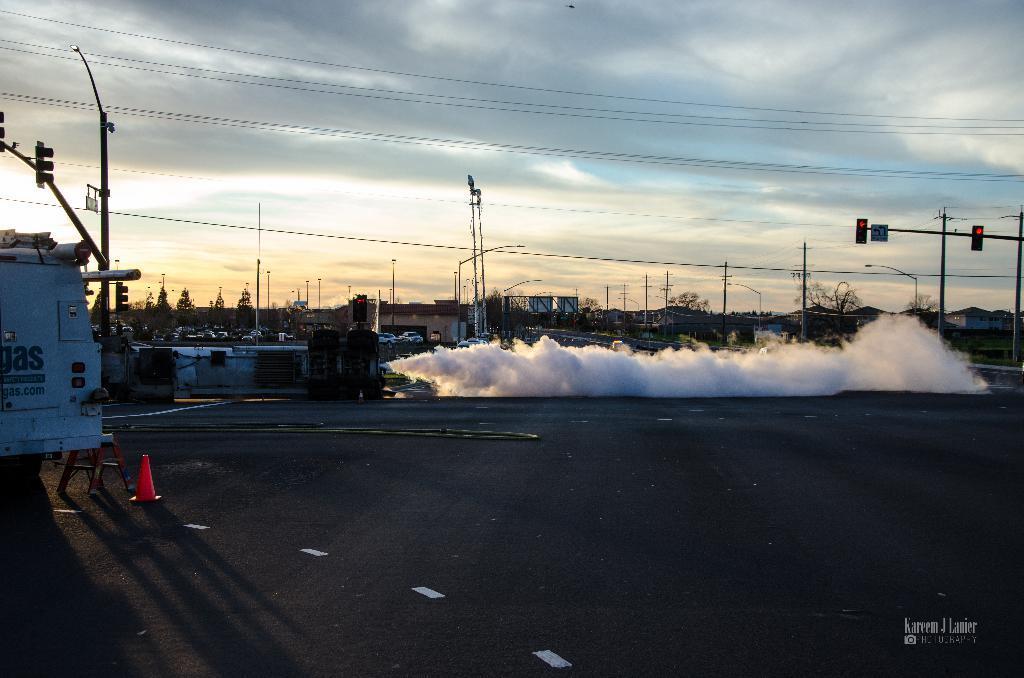Could you give a brief overview of what you see in this image? In this picture I can see vehicles on the road, there is smoke, there is a cone bar barricade and a stool, there are poles, lights, cables, there are houses, trees, and in the background there is the sky and there is a watermark on the image. 